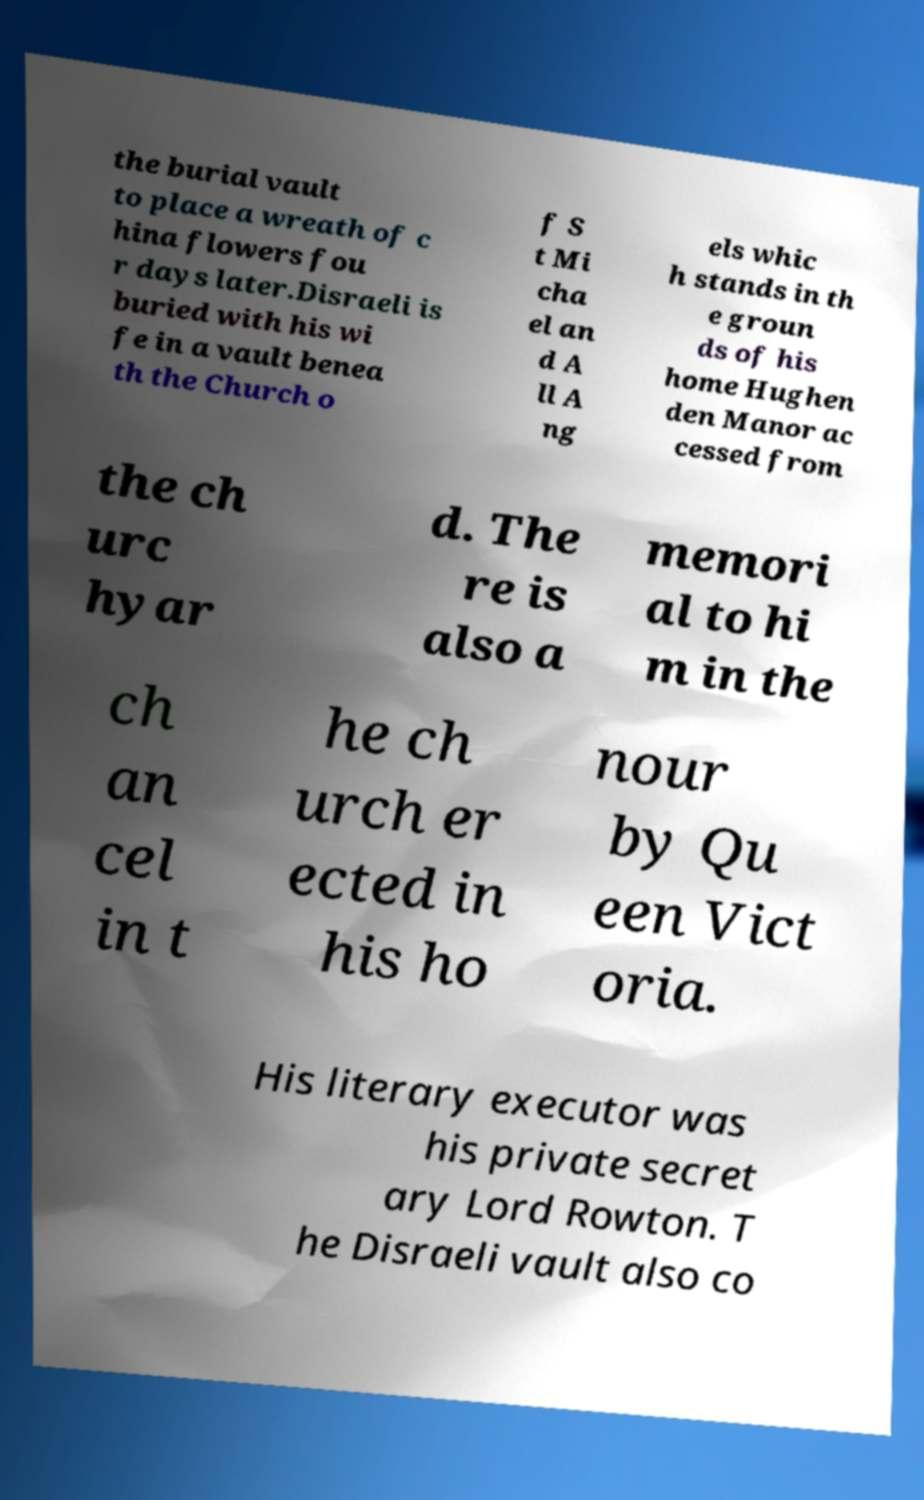I need the written content from this picture converted into text. Can you do that? the burial vault to place a wreath of c hina flowers fou r days later.Disraeli is buried with his wi fe in a vault benea th the Church o f S t Mi cha el an d A ll A ng els whic h stands in th e groun ds of his home Hughen den Manor ac cessed from the ch urc hyar d. The re is also a memori al to hi m in the ch an cel in t he ch urch er ected in his ho nour by Qu een Vict oria. His literary executor was his private secret ary Lord Rowton. T he Disraeli vault also co 